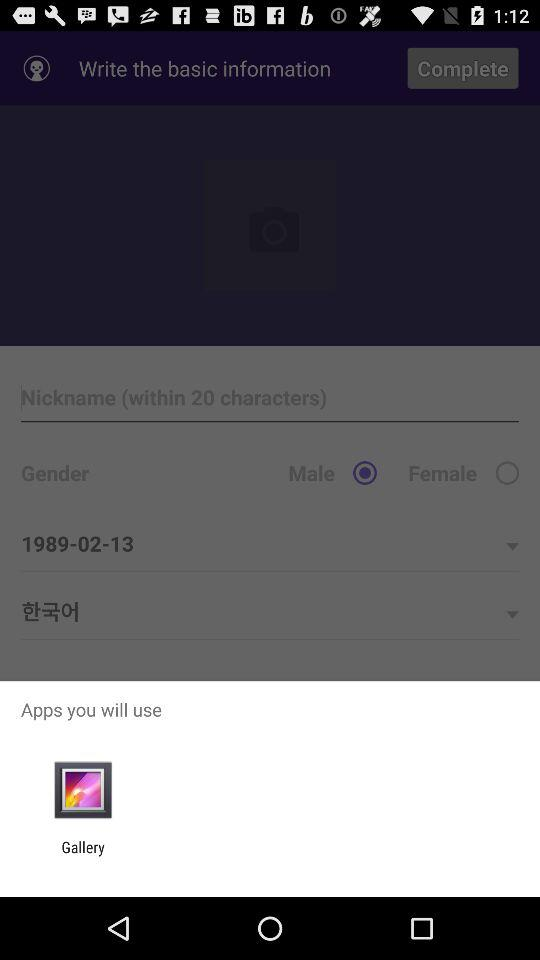What is the selected gender? The selected gender is male. 